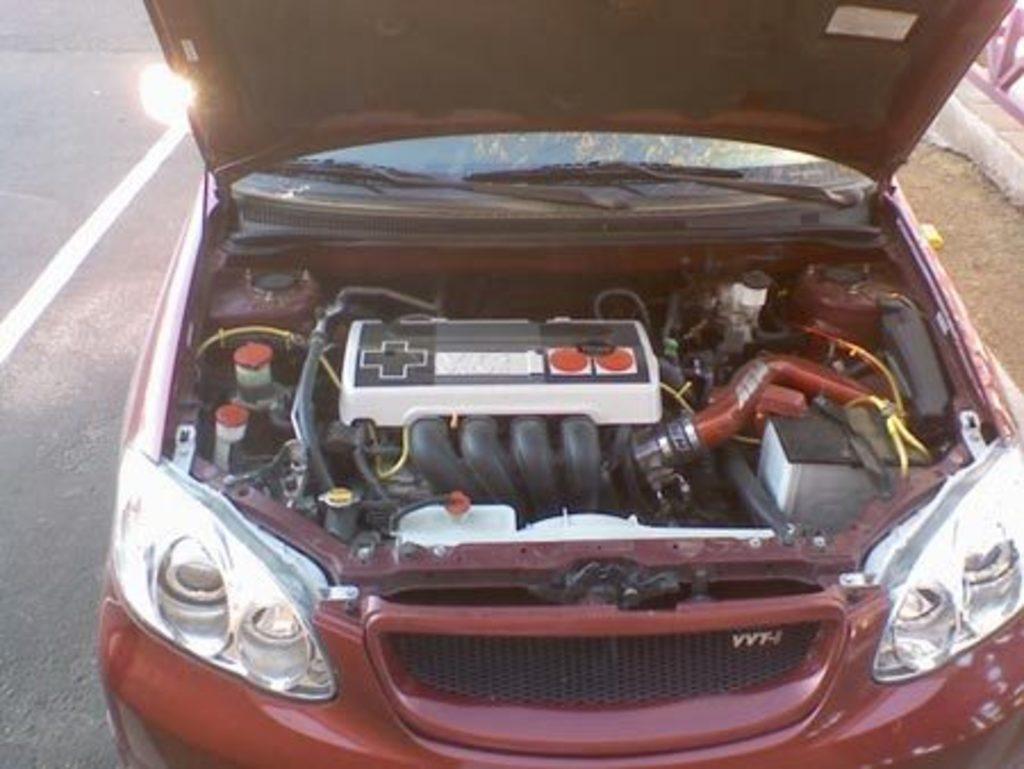Describe this image in one or two sentences. In this image we can see there is a car on the road. And there is an engine part of the car. At the side, it looks like a fence. 